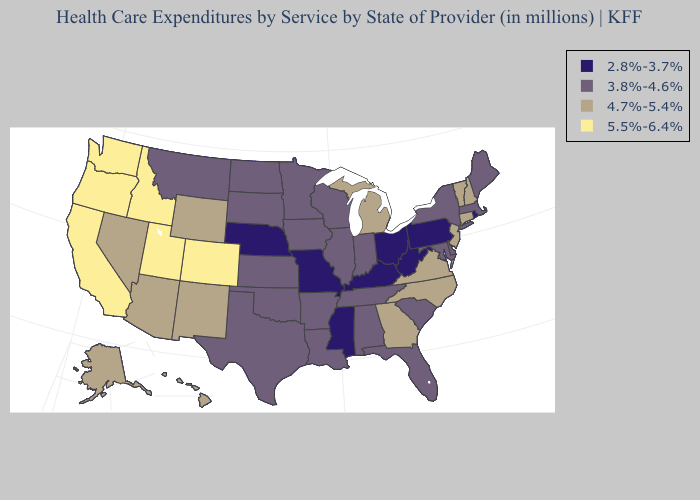What is the value of Utah?
Short answer required. 5.5%-6.4%. Name the states that have a value in the range 4.7%-5.4%?
Concise answer only. Alaska, Arizona, Connecticut, Georgia, Hawaii, Michigan, Nevada, New Hampshire, New Jersey, New Mexico, North Carolina, Vermont, Virginia, Wyoming. Among the states that border Oregon , does Nevada have the lowest value?
Be succinct. Yes. Among the states that border Michigan , which have the highest value?
Give a very brief answer. Indiana, Wisconsin. Does Kentucky have the lowest value in the USA?
Be succinct. Yes. What is the lowest value in the West?
Write a very short answer. 3.8%-4.6%. Name the states that have a value in the range 5.5%-6.4%?
Keep it brief. California, Colorado, Idaho, Oregon, Utah, Washington. Name the states that have a value in the range 5.5%-6.4%?
Answer briefly. California, Colorado, Idaho, Oregon, Utah, Washington. Does Wyoming have a lower value than Connecticut?
Give a very brief answer. No. Name the states that have a value in the range 3.8%-4.6%?
Be succinct. Alabama, Arkansas, Delaware, Florida, Illinois, Indiana, Iowa, Kansas, Louisiana, Maine, Maryland, Massachusetts, Minnesota, Montana, New York, North Dakota, Oklahoma, South Carolina, South Dakota, Tennessee, Texas, Wisconsin. Does the first symbol in the legend represent the smallest category?
Concise answer only. Yes. Does South Carolina have the same value as West Virginia?
Give a very brief answer. No. Name the states that have a value in the range 3.8%-4.6%?
Be succinct. Alabama, Arkansas, Delaware, Florida, Illinois, Indiana, Iowa, Kansas, Louisiana, Maine, Maryland, Massachusetts, Minnesota, Montana, New York, North Dakota, Oklahoma, South Carolina, South Dakota, Tennessee, Texas, Wisconsin. Among the states that border Louisiana , does Mississippi have the lowest value?
Concise answer only. Yes. Is the legend a continuous bar?
Answer briefly. No. 